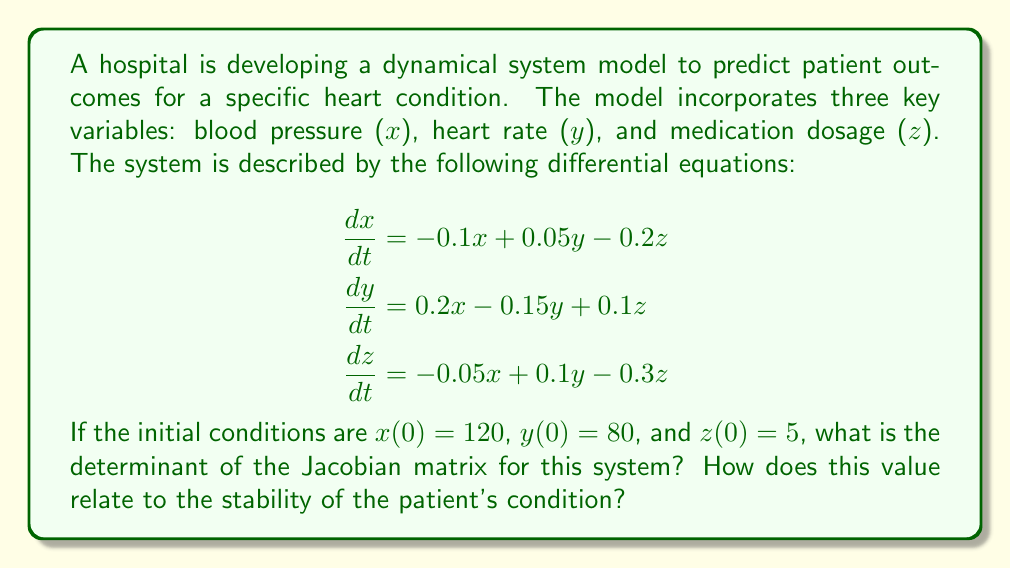Can you answer this question? To solve this problem, we'll follow these steps:

1) First, we need to construct the Jacobian matrix. The Jacobian is a matrix of all first-order partial derivatives of a vector-valued function. For our system:

   $$J = \begin{bmatrix}
   \frac{\partial \dot{x}}{\partial x} & \frac{\partial \dot{x}}{\partial y} & \frac{\partial \dot{x}}{\partial z} \\
   \frac{\partial \dot{y}}{\partial x} & \frac{\partial \dot{y}}{\partial y} & \frac{\partial \dot{y}}{\partial z} \\
   \frac{\partial \dot{z}}{\partial x} & \frac{\partial \dot{z}}{\partial y} & \frac{\partial \dot{z}}{\partial z}
   \end{bmatrix}$$

2) Calculating each partial derivative:

   $$J = \begin{bmatrix}
   -0.1 & 0.05 & -0.2 \\
   0.2 & -0.15 & 0.1 \\
   -0.05 & 0.1 & -0.3
   \end{bmatrix}$$

3) To find the determinant of a 3x3 matrix, we use the formula:

   $det(J) = a(ei-fh) - b(di-fg) + c(dh-eg)$

   where $a, b, c$ are the elements of the first row, and $d, e, f, g, h, i$ are the remaining elements.

4) Plugging in our values:

   $det(J) = (-0.1)[(-0.15)(-0.3) - (0.1)(0.1)] - (0.05)[(0.2)(-0.3) - (-0.05)(0.1)] + (-0.2)[(0.2)(0.1) - (-0.05)(-0.15)]$

5) Simplifying:

   $det(J) = (-0.1)[0.045 - 0.01] - (0.05)[-0.06 - (-0.005)] + (-0.2)[0.02 - 0.0075]$
   $det(J) = (-0.1)(0.035) - (0.05)(-0.055) + (-0.2)(0.0125)$
   $det(J) = -0.0035 + 0.00275 - 0.0025$
   $det(J) = -0.00325$

6) Interpretation: The determinant of the Jacobian is negative and close to zero. In dynamical systems theory, this suggests that the system is likely stable but potentially sensitive to changes. For patient outcomes, this could indicate that the patient's condition is currently stable but requires careful monitoring as small changes in variables could lead to significant changes in the patient's state.
Answer: -0.00325; Stable but sensitive system 